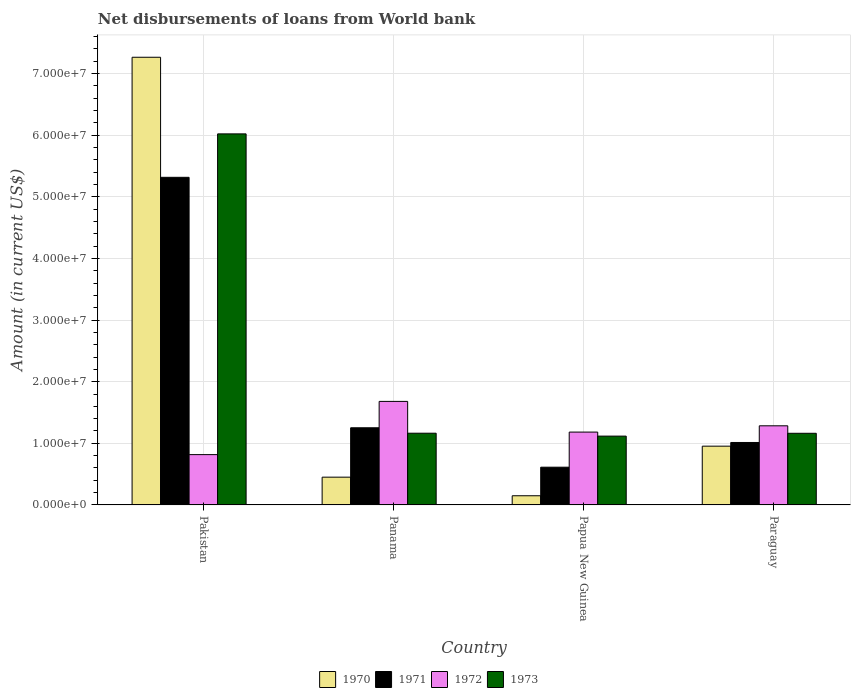How many different coloured bars are there?
Your answer should be compact. 4. Are the number of bars on each tick of the X-axis equal?
Give a very brief answer. Yes. What is the label of the 1st group of bars from the left?
Your response must be concise. Pakistan. In how many cases, is the number of bars for a given country not equal to the number of legend labels?
Provide a succinct answer. 0. What is the amount of loan disbursed from World Bank in 1970 in Papua New Guinea?
Give a very brief answer. 1.49e+06. Across all countries, what is the maximum amount of loan disbursed from World Bank in 1971?
Your answer should be compact. 5.32e+07. Across all countries, what is the minimum amount of loan disbursed from World Bank in 1971?
Offer a terse response. 6.12e+06. In which country was the amount of loan disbursed from World Bank in 1972 minimum?
Offer a very short reply. Pakistan. What is the total amount of loan disbursed from World Bank in 1973 in the graph?
Provide a succinct answer. 9.47e+07. What is the difference between the amount of loan disbursed from World Bank in 1970 in Panama and that in Paraguay?
Keep it short and to the point. -5.03e+06. What is the difference between the amount of loan disbursed from World Bank in 1971 in Pakistan and the amount of loan disbursed from World Bank in 1973 in Papua New Guinea?
Offer a very short reply. 4.20e+07. What is the average amount of loan disbursed from World Bank in 1972 per country?
Your answer should be very brief. 1.24e+07. What is the difference between the amount of loan disbursed from World Bank of/in 1973 and amount of loan disbursed from World Bank of/in 1972 in Paraguay?
Your answer should be very brief. -1.22e+06. What is the ratio of the amount of loan disbursed from World Bank in 1972 in Pakistan to that in Paraguay?
Make the answer very short. 0.64. Is the difference between the amount of loan disbursed from World Bank in 1973 in Pakistan and Panama greater than the difference between the amount of loan disbursed from World Bank in 1972 in Pakistan and Panama?
Your answer should be very brief. Yes. What is the difference between the highest and the second highest amount of loan disbursed from World Bank in 1970?
Make the answer very short. 6.81e+07. What is the difference between the highest and the lowest amount of loan disbursed from World Bank in 1973?
Offer a very short reply. 4.91e+07. In how many countries, is the amount of loan disbursed from World Bank in 1972 greater than the average amount of loan disbursed from World Bank in 1972 taken over all countries?
Provide a succinct answer. 2. Is it the case that in every country, the sum of the amount of loan disbursed from World Bank in 1973 and amount of loan disbursed from World Bank in 1971 is greater than the sum of amount of loan disbursed from World Bank in 1972 and amount of loan disbursed from World Bank in 1970?
Your answer should be very brief. No. What does the 2nd bar from the right in Paraguay represents?
Offer a terse response. 1972. How many bars are there?
Ensure brevity in your answer.  16. Are the values on the major ticks of Y-axis written in scientific E-notation?
Make the answer very short. Yes. How many legend labels are there?
Keep it short and to the point. 4. How are the legend labels stacked?
Your answer should be compact. Horizontal. What is the title of the graph?
Give a very brief answer. Net disbursements of loans from World bank. What is the Amount (in current US$) in 1970 in Pakistan?
Provide a short and direct response. 7.27e+07. What is the Amount (in current US$) of 1971 in Pakistan?
Give a very brief answer. 5.32e+07. What is the Amount (in current US$) in 1972 in Pakistan?
Keep it short and to the point. 8.17e+06. What is the Amount (in current US$) of 1973 in Pakistan?
Your response must be concise. 6.02e+07. What is the Amount (in current US$) of 1970 in Panama?
Ensure brevity in your answer.  4.51e+06. What is the Amount (in current US$) in 1971 in Panama?
Offer a very short reply. 1.25e+07. What is the Amount (in current US$) of 1972 in Panama?
Offer a very short reply. 1.68e+07. What is the Amount (in current US$) of 1973 in Panama?
Your answer should be very brief. 1.16e+07. What is the Amount (in current US$) in 1970 in Papua New Guinea?
Give a very brief answer. 1.49e+06. What is the Amount (in current US$) in 1971 in Papua New Guinea?
Offer a terse response. 6.12e+06. What is the Amount (in current US$) in 1972 in Papua New Guinea?
Your answer should be very brief. 1.18e+07. What is the Amount (in current US$) in 1973 in Papua New Guinea?
Provide a succinct answer. 1.12e+07. What is the Amount (in current US$) in 1970 in Paraguay?
Your answer should be very brief. 9.54e+06. What is the Amount (in current US$) in 1971 in Paraguay?
Offer a terse response. 1.01e+07. What is the Amount (in current US$) of 1972 in Paraguay?
Your response must be concise. 1.28e+07. What is the Amount (in current US$) in 1973 in Paraguay?
Give a very brief answer. 1.16e+07. Across all countries, what is the maximum Amount (in current US$) of 1970?
Make the answer very short. 7.27e+07. Across all countries, what is the maximum Amount (in current US$) in 1971?
Offer a very short reply. 5.32e+07. Across all countries, what is the maximum Amount (in current US$) in 1972?
Your answer should be very brief. 1.68e+07. Across all countries, what is the maximum Amount (in current US$) of 1973?
Your response must be concise. 6.02e+07. Across all countries, what is the minimum Amount (in current US$) in 1970?
Your response must be concise. 1.49e+06. Across all countries, what is the minimum Amount (in current US$) of 1971?
Make the answer very short. 6.12e+06. Across all countries, what is the minimum Amount (in current US$) in 1972?
Your answer should be compact. 8.17e+06. Across all countries, what is the minimum Amount (in current US$) in 1973?
Provide a short and direct response. 1.12e+07. What is the total Amount (in current US$) in 1970 in the graph?
Your response must be concise. 8.82e+07. What is the total Amount (in current US$) of 1971 in the graph?
Your response must be concise. 8.20e+07. What is the total Amount (in current US$) of 1972 in the graph?
Give a very brief answer. 4.96e+07. What is the total Amount (in current US$) of 1973 in the graph?
Provide a succinct answer. 9.47e+07. What is the difference between the Amount (in current US$) of 1970 in Pakistan and that in Panama?
Your response must be concise. 6.81e+07. What is the difference between the Amount (in current US$) of 1971 in Pakistan and that in Panama?
Keep it short and to the point. 4.06e+07. What is the difference between the Amount (in current US$) of 1972 in Pakistan and that in Panama?
Make the answer very short. -8.64e+06. What is the difference between the Amount (in current US$) of 1973 in Pakistan and that in Panama?
Your answer should be compact. 4.86e+07. What is the difference between the Amount (in current US$) of 1970 in Pakistan and that in Papua New Guinea?
Offer a very short reply. 7.12e+07. What is the difference between the Amount (in current US$) of 1971 in Pakistan and that in Papua New Guinea?
Keep it short and to the point. 4.70e+07. What is the difference between the Amount (in current US$) in 1972 in Pakistan and that in Papua New Guinea?
Keep it short and to the point. -3.66e+06. What is the difference between the Amount (in current US$) of 1973 in Pakistan and that in Papua New Guinea?
Your answer should be compact. 4.91e+07. What is the difference between the Amount (in current US$) in 1970 in Pakistan and that in Paraguay?
Your answer should be very brief. 6.31e+07. What is the difference between the Amount (in current US$) in 1971 in Pakistan and that in Paraguay?
Provide a succinct answer. 4.30e+07. What is the difference between the Amount (in current US$) in 1972 in Pakistan and that in Paraguay?
Offer a terse response. -4.68e+06. What is the difference between the Amount (in current US$) in 1973 in Pakistan and that in Paraguay?
Provide a short and direct response. 4.86e+07. What is the difference between the Amount (in current US$) of 1970 in Panama and that in Papua New Guinea?
Your answer should be very brief. 3.02e+06. What is the difference between the Amount (in current US$) of 1971 in Panama and that in Papua New Guinea?
Ensure brevity in your answer.  6.40e+06. What is the difference between the Amount (in current US$) of 1972 in Panama and that in Papua New Guinea?
Give a very brief answer. 4.98e+06. What is the difference between the Amount (in current US$) in 1973 in Panama and that in Papua New Guinea?
Offer a very short reply. 4.71e+05. What is the difference between the Amount (in current US$) in 1970 in Panama and that in Paraguay?
Offer a terse response. -5.03e+06. What is the difference between the Amount (in current US$) of 1971 in Panama and that in Paraguay?
Provide a succinct answer. 2.38e+06. What is the difference between the Amount (in current US$) in 1972 in Panama and that in Paraguay?
Your response must be concise. 3.96e+06. What is the difference between the Amount (in current US$) in 1973 in Panama and that in Paraguay?
Your answer should be very brief. 1.30e+04. What is the difference between the Amount (in current US$) in 1970 in Papua New Guinea and that in Paraguay?
Offer a very short reply. -8.05e+06. What is the difference between the Amount (in current US$) of 1971 in Papua New Guinea and that in Paraguay?
Give a very brief answer. -4.01e+06. What is the difference between the Amount (in current US$) in 1972 in Papua New Guinea and that in Paraguay?
Make the answer very short. -1.02e+06. What is the difference between the Amount (in current US$) in 1973 in Papua New Guinea and that in Paraguay?
Your response must be concise. -4.58e+05. What is the difference between the Amount (in current US$) of 1970 in Pakistan and the Amount (in current US$) of 1971 in Panama?
Your response must be concise. 6.01e+07. What is the difference between the Amount (in current US$) of 1970 in Pakistan and the Amount (in current US$) of 1972 in Panama?
Your answer should be compact. 5.59e+07. What is the difference between the Amount (in current US$) of 1970 in Pakistan and the Amount (in current US$) of 1973 in Panama?
Provide a short and direct response. 6.10e+07. What is the difference between the Amount (in current US$) of 1971 in Pakistan and the Amount (in current US$) of 1972 in Panama?
Your answer should be compact. 3.64e+07. What is the difference between the Amount (in current US$) of 1971 in Pakistan and the Amount (in current US$) of 1973 in Panama?
Keep it short and to the point. 4.15e+07. What is the difference between the Amount (in current US$) in 1972 in Pakistan and the Amount (in current US$) in 1973 in Panama?
Give a very brief answer. -3.47e+06. What is the difference between the Amount (in current US$) of 1970 in Pakistan and the Amount (in current US$) of 1971 in Papua New Guinea?
Offer a very short reply. 6.65e+07. What is the difference between the Amount (in current US$) of 1970 in Pakistan and the Amount (in current US$) of 1972 in Papua New Guinea?
Your response must be concise. 6.08e+07. What is the difference between the Amount (in current US$) of 1970 in Pakistan and the Amount (in current US$) of 1973 in Papua New Guinea?
Offer a very short reply. 6.15e+07. What is the difference between the Amount (in current US$) of 1971 in Pakistan and the Amount (in current US$) of 1972 in Papua New Guinea?
Provide a short and direct response. 4.13e+07. What is the difference between the Amount (in current US$) in 1971 in Pakistan and the Amount (in current US$) in 1973 in Papua New Guinea?
Give a very brief answer. 4.20e+07. What is the difference between the Amount (in current US$) in 1972 in Pakistan and the Amount (in current US$) in 1973 in Papua New Guinea?
Provide a succinct answer. -3.00e+06. What is the difference between the Amount (in current US$) of 1970 in Pakistan and the Amount (in current US$) of 1971 in Paraguay?
Offer a very short reply. 6.25e+07. What is the difference between the Amount (in current US$) in 1970 in Pakistan and the Amount (in current US$) in 1972 in Paraguay?
Ensure brevity in your answer.  5.98e+07. What is the difference between the Amount (in current US$) of 1970 in Pakistan and the Amount (in current US$) of 1973 in Paraguay?
Make the answer very short. 6.10e+07. What is the difference between the Amount (in current US$) in 1971 in Pakistan and the Amount (in current US$) in 1972 in Paraguay?
Offer a very short reply. 4.03e+07. What is the difference between the Amount (in current US$) of 1971 in Pakistan and the Amount (in current US$) of 1973 in Paraguay?
Provide a succinct answer. 4.15e+07. What is the difference between the Amount (in current US$) in 1972 in Pakistan and the Amount (in current US$) in 1973 in Paraguay?
Keep it short and to the point. -3.46e+06. What is the difference between the Amount (in current US$) in 1970 in Panama and the Amount (in current US$) in 1971 in Papua New Guinea?
Offer a terse response. -1.62e+06. What is the difference between the Amount (in current US$) in 1970 in Panama and the Amount (in current US$) in 1972 in Papua New Guinea?
Provide a short and direct response. -7.32e+06. What is the difference between the Amount (in current US$) of 1970 in Panama and the Amount (in current US$) of 1973 in Papua New Guinea?
Ensure brevity in your answer.  -6.66e+06. What is the difference between the Amount (in current US$) of 1971 in Panama and the Amount (in current US$) of 1972 in Papua New Guinea?
Your answer should be compact. 6.99e+05. What is the difference between the Amount (in current US$) in 1971 in Panama and the Amount (in current US$) in 1973 in Papua New Guinea?
Your answer should be compact. 1.35e+06. What is the difference between the Amount (in current US$) of 1972 in Panama and the Amount (in current US$) of 1973 in Papua New Guinea?
Make the answer very short. 5.64e+06. What is the difference between the Amount (in current US$) of 1970 in Panama and the Amount (in current US$) of 1971 in Paraguay?
Offer a terse response. -5.63e+06. What is the difference between the Amount (in current US$) of 1970 in Panama and the Amount (in current US$) of 1972 in Paraguay?
Your answer should be compact. -8.33e+06. What is the difference between the Amount (in current US$) of 1970 in Panama and the Amount (in current US$) of 1973 in Paraguay?
Offer a terse response. -7.12e+06. What is the difference between the Amount (in current US$) in 1971 in Panama and the Amount (in current US$) in 1972 in Paraguay?
Provide a short and direct response. -3.20e+05. What is the difference between the Amount (in current US$) in 1971 in Panama and the Amount (in current US$) in 1973 in Paraguay?
Offer a terse response. 8.95e+05. What is the difference between the Amount (in current US$) in 1972 in Panama and the Amount (in current US$) in 1973 in Paraguay?
Keep it short and to the point. 5.18e+06. What is the difference between the Amount (in current US$) of 1970 in Papua New Guinea and the Amount (in current US$) of 1971 in Paraguay?
Offer a very short reply. -8.65e+06. What is the difference between the Amount (in current US$) in 1970 in Papua New Guinea and the Amount (in current US$) in 1972 in Paraguay?
Your answer should be compact. -1.14e+07. What is the difference between the Amount (in current US$) of 1970 in Papua New Guinea and the Amount (in current US$) of 1973 in Paraguay?
Offer a very short reply. -1.01e+07. What is the difference between the Amount (in current US$) of 1971 in Papua New Guinea and the Amount (in current US$) of 1972 in Paraguay?
Offer a terse response. -6.72e+06. What is the difference between the Amount (in current US$) of 1971 in Papua New Guinea and the Amount (in current US$) of 1973 in Paraguay?
Ensure brevity in your answer.  -5.50e+06. What is the difference between the Amount (in current US$) of 1972 in Papua New Guinea and the Amount (in current US$) of 1973 in Paraguay?
Make the answer very short. 1.96e+05. What is the average Amount (in current US$) in 1970 per country?
Keep it short and to the point. 2.20e+07. What is the average Amount (in current US$) in 1971 per country?
Provide a succinct answer. 2.05e+07. What is the average Amount (in current US$) in 1972 per country?
Offer a terse response. 1.24e+07. What is the average Amount (in current US$) of 1973 per country?
Your response must be concise. 2.37e+07. What is the difference between the Amount (in current US$) of 1970 and Amount (in current US$) of 1971 in Pakistan?
Provide a succinct answer. 1.95e+07. What is the difference between the Amount (in current US$) of 1970 and Amount (in current US$) of 1972 in Pakistan?
Your answer should be compact. 6.45e+07. What is the difference between the Amount (in current US$) of 1970 and Amount (in current US$) of 1973 in Pakistan?
Offer a terse response. 1.24e+07. What is the difference between the Amount (in current US$) of 1971 and Amount (in current US$) of 1972 in Pakistan?
Give a very brief answer. 4.50e+07. What is the difference between the Amount (in current US$) of 1971 and Amount (in current US$) of 1973 in Pakistan?
Offer a terse response. -7.05e+06. What is the difference between the Amount (in current US$) in 1972 and Amount (in current US$) in 1973 in Pakistan?
Keep it short and to the point. -5.21e+07. What is the difference between the Amount (in current US$) in 1970 and Amount (in current US$) in 1971 in Panama?
Your answer should be compact. -8.01e+06. What is the difference between the Amount (in current US$) of 1970 and Amount (in current US$) of 1972 in Panama?
Give a very brief answer. -1.23e+07. What is the difference between the Amount (in current US$) of 1970 and Amount (in current US$) of 1973 in Panama?
Your answer should be compact. -7.13e+06. What is the difference between the Amount (in current US$) in 1971 and Amount (in current US$) in 1972 in Panama?
Give a very brief answer. -4.28e+06. What is the difference between the Amount (in current US$) in 1971 and Amount (in current US$) in 1973 in Panama?
Make the answer very short. 8.82e+05. What is the difference between the Amount (in current US$) of 1972 and Amount (in current US$) of 1973 in Panama?
Provide a succinct answer. 5.16e+06. What is the difference between the Amount (in current US$) in 1970 and Amount (in current US$) in 1971 in Papua New Guinea?
Provide a succinct answer. -4.63e+06. What is the difference between the Amount (in current US$) of 1970 and Amount (in current US$) of 1972 in Papua New Guinea?
Your response must be concise. -1.03e+07. What is the difference between the Amount (in current US$) in 1970 and Amount (in current US$) in 1973 in Papua New Guinea?
Provide a short and direct response. -9.68e+06. What is the difference between the Amount (in current US$) in 1971 and Amount (in current US$) in 1972 in Papua New Guinea?
Make the answer very short. -5.70e+06. What is the difference between the Amount (in current US$) of 1971 and Amount (in current US$) of 1973 in Papua New Guinea?
Offer a very short reply. -5.04e+06. What is the difference between the Amount (in current US$) in 1972 and Amount (in current US$) in 1973 in Papua New Guinea?
Ensure brevity in your answer.  6.54e+05. What is the difference between the Amount (in current US$) in 1970 and Amount (in current US$) in 1971 in Paraguay?
Your answer should be very brief. -5.99e+05. What is the difference between the Amount (in current US$) of 1970 and Amount (in current US$) of 1972 in Paraguay?
Keep it short and to the point. -3.30e+06. What is the difference between the Amount (in current US$) in 1970 and Amount (in current US$) in 1973 in Paraguay?
Provide a short and direct response. -2.09e+06. What is the difference between the Amount (in current US$) of 1971 and Amount (in current US$) of 1972 in Paraguay?
Offer a very short reply. -2.70e+06. What is the difference between the Amount (in current US$) in 1971 and Amount (in current US$) in 1973 in Paraguay?
Your answer should be very brief. -1.49e+06. What is the difference between the Amount (in current US$) of 1972 and Amount (in current US$) of 1973 in Paraguay?
Provide a short and direct response. 1.22e+06. What is the ratio of the Amount (in current US$) of 1970 in Pakistan to that in Panama?
Provide a short and direct response. 16.12. What is the ratio of the Amount (in current US$) in 1971 in Pakistan to that in Panama?
Offer a very short reply. 4.25. What is the ratio of the Amount (in current US$) in 1972 in Pakistan to that in Panama?
Your answer should be compact. 0.49. What is the ratio of the Amount (in current US$) of 1973 in Pakistan to that in Panama?
Your answer should be compact. 5.17. What is the ratio of the Amount (in current US$) of 1970 in Pakistan to that in Papua New Guinea?
Keep it short and to the point. 48.76. What is the ratio of the Amount (in current US$) of 1971 in Pakistan to that in Papua New Guinea?
Make the answer very short. 8.68. What is the ratio of the Amount (in current US$) in 1972 in Pakistan to that in Papua New Guinea?
Your answer should be very brief. 0.69. What is the ratio of the Amount (in current US$) of 1973 in Pakistan to that in Papua New Guinea?
Your answer should be very brief. 5.39. What is the ratio of the Amount (in current US$) in 1970 in Pakistan to that in Paraguay?
Give a very brief answer. 7.62. What is the ratio of the Amount (in current US$) in 1971 in Pakistan to that in Paraguay?
Make the answer very short. 5.25. What is the ratio of the Amount (in current US$) of 1972 in Pakistan to that in Paraguay?
Ensure brevity in your answer.  0.64. What is the ratio of the Amount (in current US$) in 1973 in Pakistan to that in Paraguay?
Make the answer very short. 5.18. What is the ratio of the Amount (in current US$) of 1970 in Panama to that in Papua New Guinea?
Your answer should be compact. 3.03. What is the ratio of the Amount (in current US$) of 1971 in Panama to that in Papua New Guinea?
Offer a very short reply. 2.04. What is the ratio of the Amount (in current US$) in 1972 in Panama to that in Papua New Guinea?
Your answer should be compact. 1.42. What is the ratio of the Amount (in current US$) of 1973 in Panama to that in Papua New Guinea?
Make the answer very short. 1.04. What is the ratio of the Amount (in current US$) in 1970 in Panama to that in Paraguay?
Ensure brevity in your answer.  0.47. What is the ratio of the Amount (in current US$) of 1971 in Panama to that in Paraguay?
Keep it short and to the point. 1.24. What is the ratio of the Amount (in current US$) of 1972 in Panama to that in Paraguay?
Offer a terse response. 1.31. What is the ratio of the Amount (in current US$) of 1970 in Papua New Guinea to that in Paraguay?
Provide a succinct answer. 0.16. What is the ratio of the Amount (in current US$) in 1971 in Papua New Guinea to that in Paraguay?
Your response must be concise. 0.6. What is the ratio of the Amount (in current US$) of 1972 in Papua New Guinea to that in Paraguay?
Provide a short and direct response. 0.92. What is the ratio of the Amount (in current US$) of 1973 in Papua New Guinea to that in Paraguay?
Keep it short and to the point. 0.96. What is the difference between the highest and the second highest Amount (in current US$) in 1970?
Make the answer very short. 6.31e+07. What is the difference between the highest and the second highest Amount (in current US$) of 1971?
Ensure brevity in your answer.  4.06e+07. What is the difference between the highest and the second highest Amount (in current US$) in 1972?
Provide a short and direct response. 3.96e+06. What is the difference between the highest and the second highest Amount (in current US$) in 1973?
Give a very brief answer. 4.86e+07. What is the difference between the highest and the lowest Amount (in current US$) in 1970?
Make the answer very short. 7.12e+07. What is the difference between the highest and the lowest Amount (in current US$) in 1971?
Your answer should be compact. 4.70e+07. What is the difference between the highest and the lowest Amount (in current US$) of 1972?
Offer a very short reply. 8.64e+06. What is the difference between the highest and the lowest Amount (in current US$) of 1973?
Give a very brief answer. 4.91e+07. 